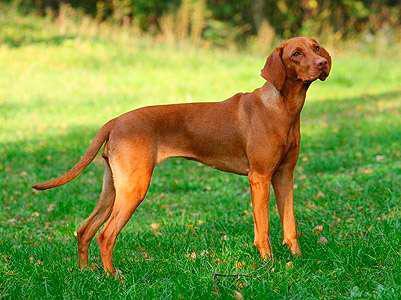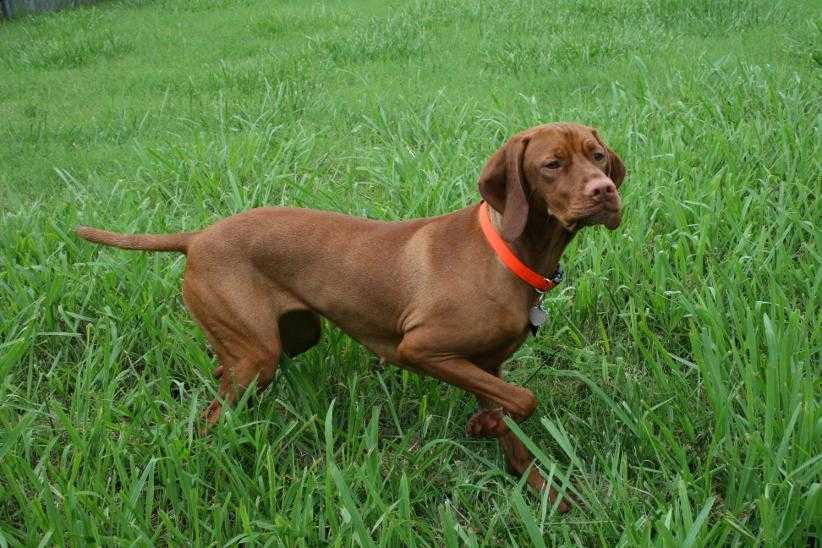The first image is the image on the left, the second image is the image on the right. Assess this claim about the two images: "The dog in the image on the right is on a leash.". Correct or not? Answer yes or no. No. The first image is the image on the left, the second image is the image on the right. Assess this claim about the two images: "One image shows a dog standing in profile with its body turned leftward, and the other image shows a dog standing with its body turned rightward and with one front paw raised.". Correct or not? Answer yes or no. No. 